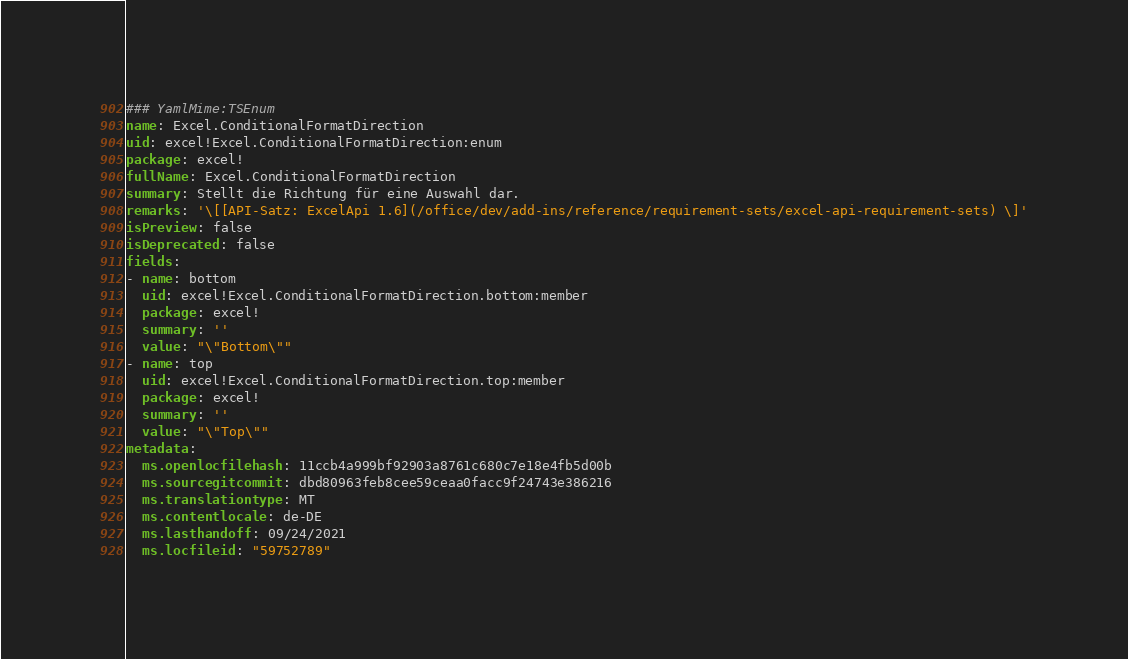<code> <loc_0><loc_0><loc_500><loc_500><_YAML_>### YamlMime:TSEnum
name: Excel.ConditionalFormatDirection
uid: excel!Excel.ConditionalFormatDirection:enum
package: excel!
fullName: Excel.ConditionalFormatDirection
summary: Stellt die Richtung für eine Auswahl dar.
remarks: '\[[API-Satz: ExcelApi 1.6](/office/dev/add-ins/reference/requirement-sets/excel-api-requirement-sets) \]'
isPreview: false
isDeprecated: false
fields:
- name: bottom
  uid: excel!Excel.ConditionalFormatDirection.bottom:member
  package: excel!
  summary: ''
  value: "\"Bottom\""
- name: top
  uid: excel!Excel.ConditionalFormatDirection.top:member
  package: excel!
  summary: ''
  value: "\"Top\""
metadata:
  ms.openlocfilehash: 11ccb4a999bf92903a8761c680c7e18e4fb5d00b
  ms.sourcegitcommit: dbd80963feb8cee59ceaa0facc9f24743e386216
  ms.translationtype: MT
  ms.contentlocale: de-DE
  ms.lasthandoff: 09/24/2021
  ms.locfileid: "59752789"
</code> 